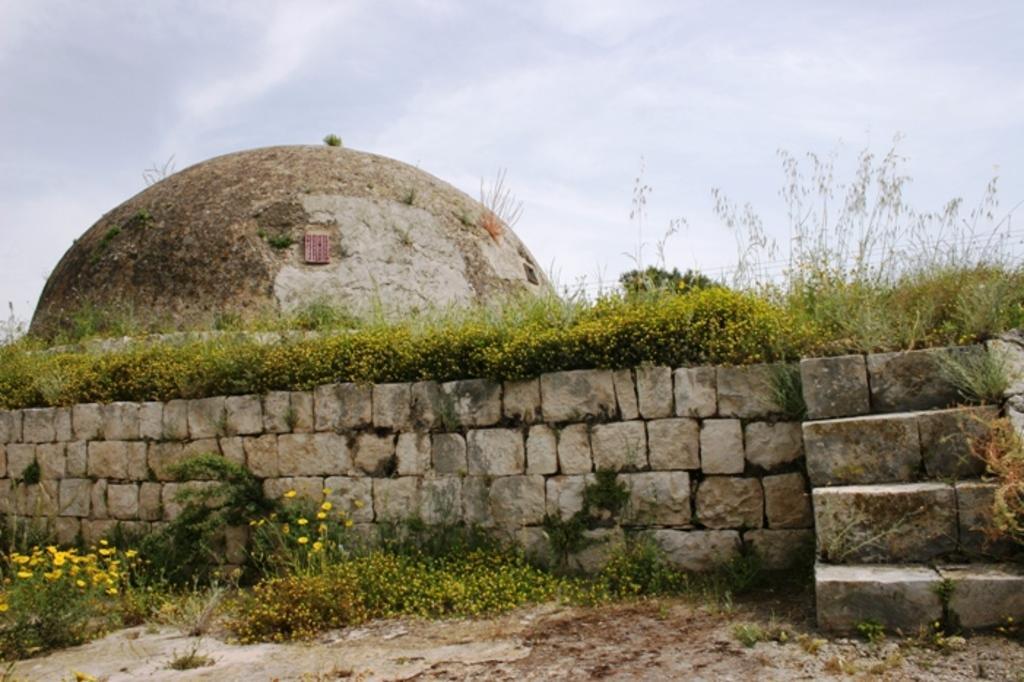How would you summarize this image in a sentence or two? In this picture there is wall at the bottom side of the and there are stairs on the right side of the image, there is greenery in the image. 